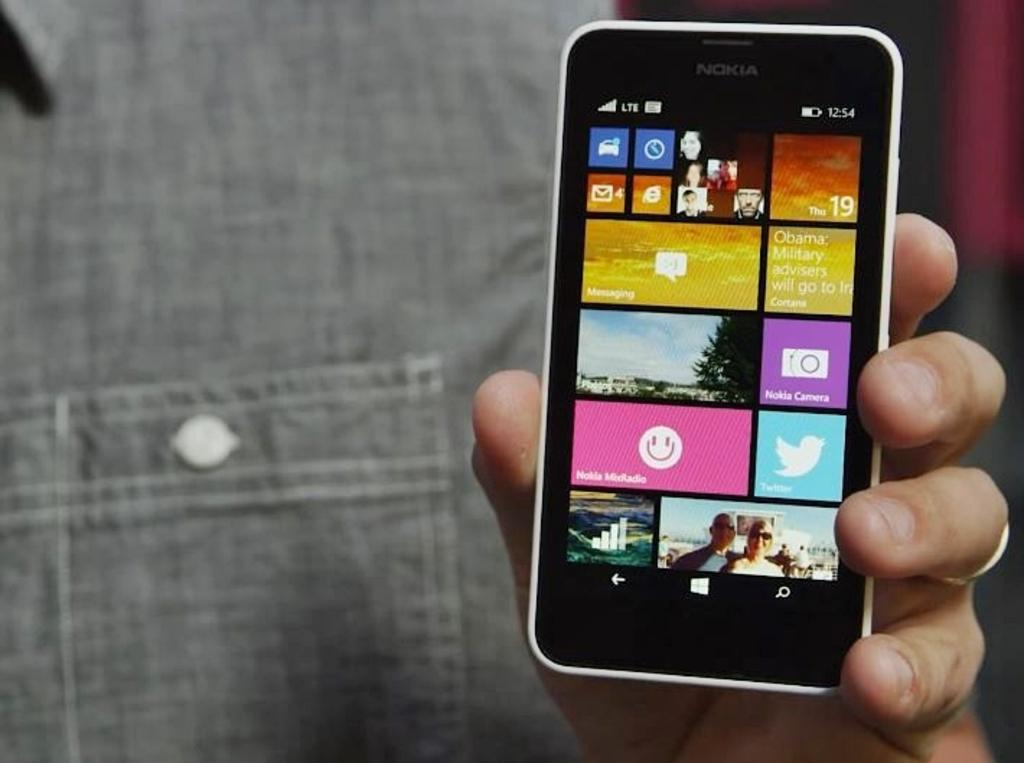<image>
Render a clear and concise summary of the photo. a phone with the word Nokia on one of the parts 